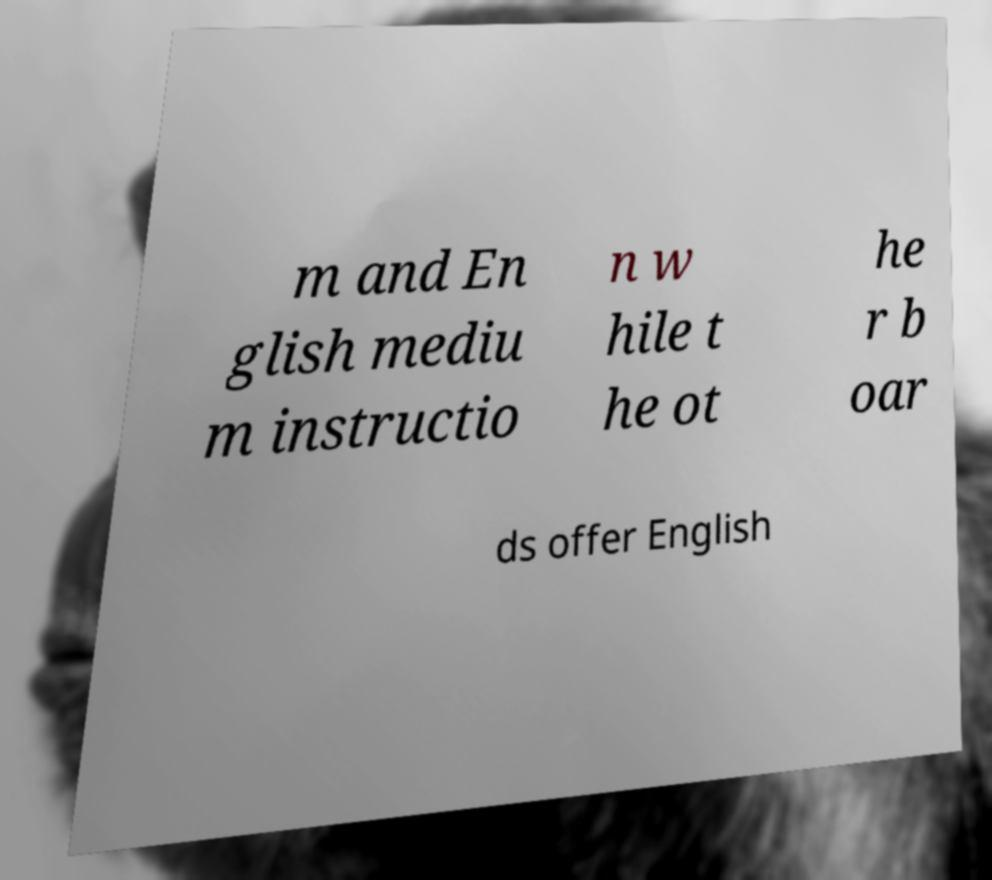Please identify and transcribe the text found in this image. m and En glish mediu m instructio n w hile t he ot he r b oar ds offer English 